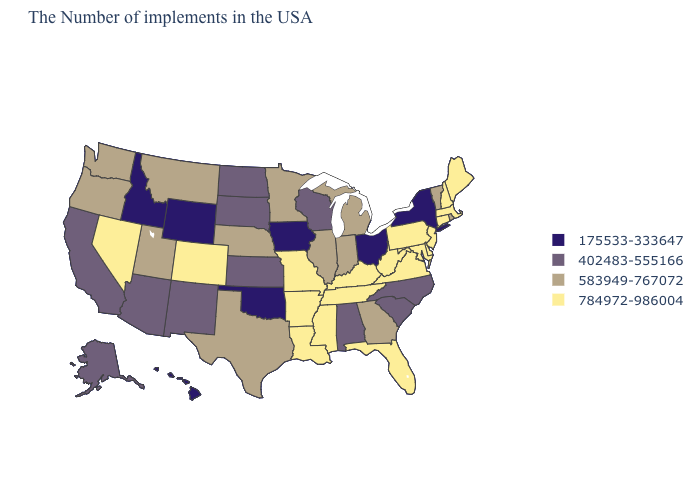Name the states that have a value in the range 784972-986004?
Give a very brief answer. Maine, Massachusetts, New Hampshire, Connecticut, New Jersey, Delaware, Maryland, Pennsylvania, Virginia, West Virginia, Florida, Kentucky, Tennessee, Mississippi, Louisiana, Missouri, Arkansas, Colorado, Nevada. Does the map have missing data?
Give a very brief answer. No. What is the value of Hawaii?
Short answer required. 175533-333647. Name the states that have a value in the range 784972-986004?
Answer briefly. Maine, Massachusetts, New Hampshire, Connecticut, New Jersey, Delaware, Maryland, Pennsylvania, Virginia, West Virginia, Florida, Kentucky, Tennessee, Mississippi, Louisiana, Missouri, Arkansas, Colorado, Nevada. Does the first symbol in the legend represent the smallest category?
Concise answer only. Yes. Is the legend a continuous bar?
Answer briefly. No. What is the highest value in the USA?
Short answer required. 784972-986004. Among the states that border Louisiana , which have the highest value?
Answer briefly. Mississippi, Arkansas. Name the states that have a value in the range 402483-555166?
Quick response, please. North Carolina, South Carolina, Alabama, Wisconsin, Kansas, South Dakota, North Dakota, New Mexico, Arizona, California, Alaska. Is the legend a continuous bar?
Quick response, please. No. Among the states that border Colorado , does New Mexico have the lowest value?
Short answer required. No. What is the value of Alabama?
Quick response, please. 402483-555166. Among the states that border Pennsylvania , which have the lowest value?
Be succinct. New York, Ohio. 